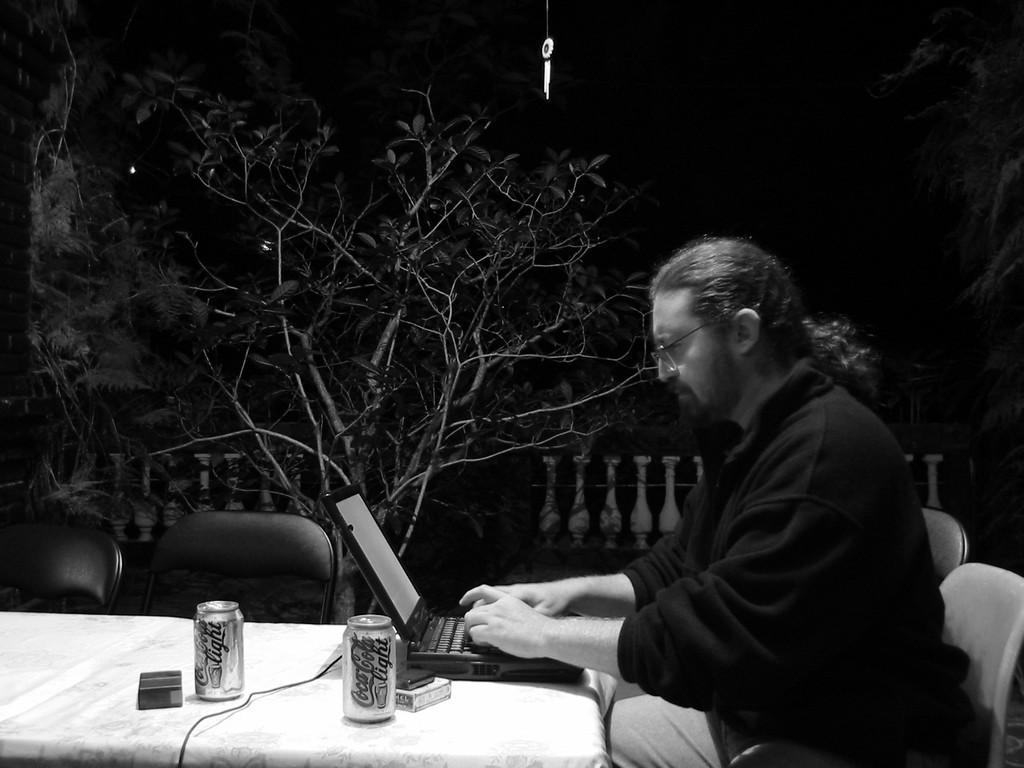How would you summarize this image in a sentence or two? In this image I can see a person sitting and working on the laptop. I can also see two tins on the table, background I can see dried trees. 